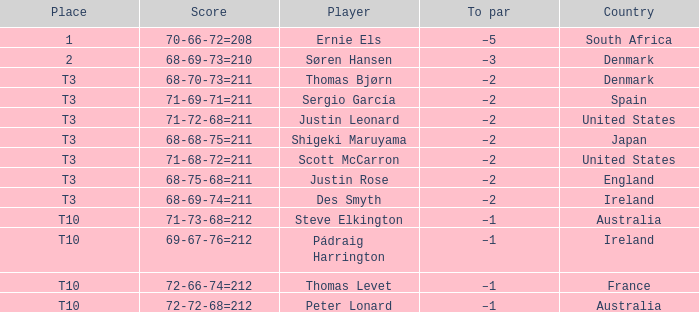What player scored 71-69-71=211? Sergio García. 